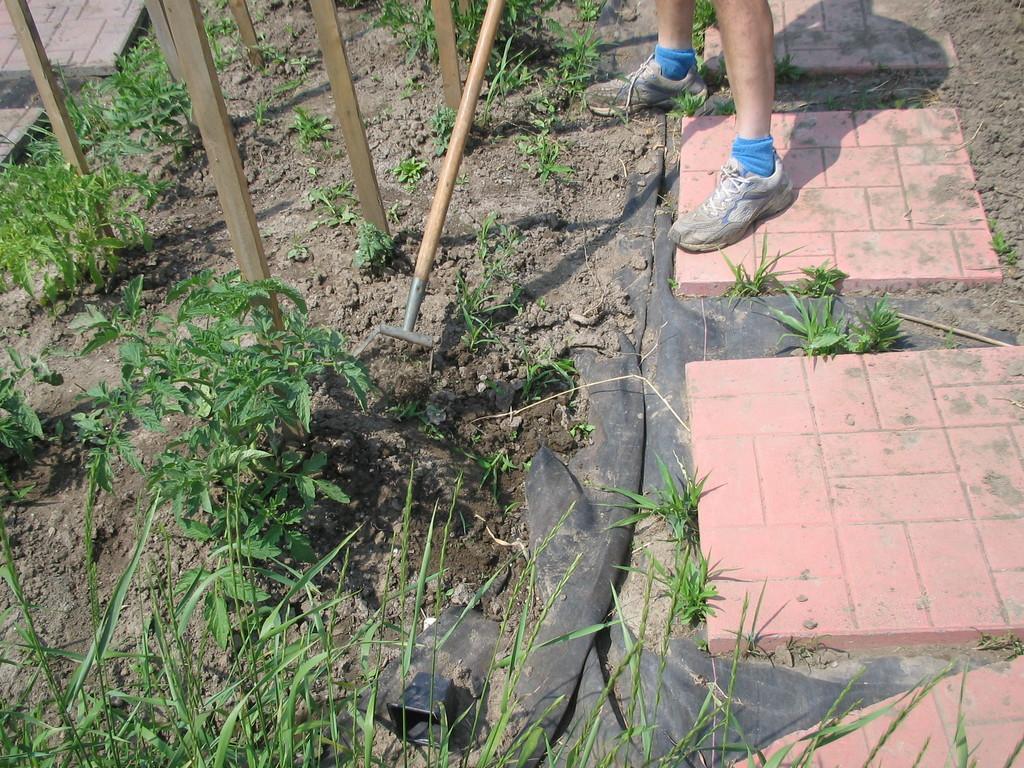Describe this image in one or two sentences. In this image I can see persons legs. Here I can see grass, wooden poles and some other objects on the ground. 